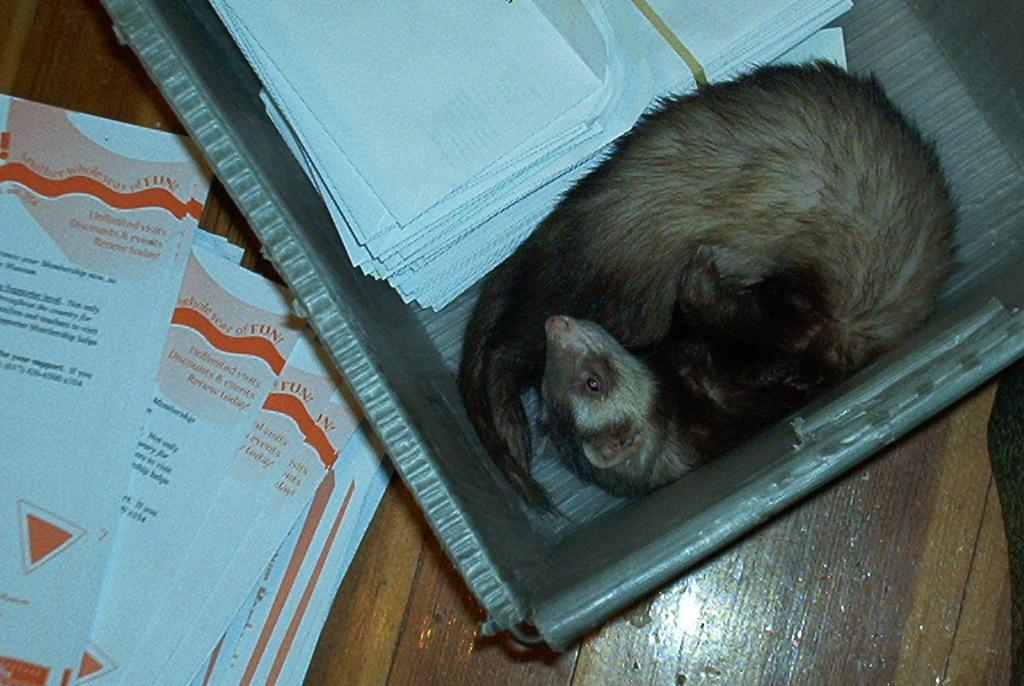What is inside the box in the image? There is an animal and papers in the box. What else can be seen in the box besides the animal? There are papers in the box. What is on the floor in the image? There are papers on the floor. What language is the animal speaking in the image? Animals do not speak human languages, so there is no language spoken by the animal in the image. 